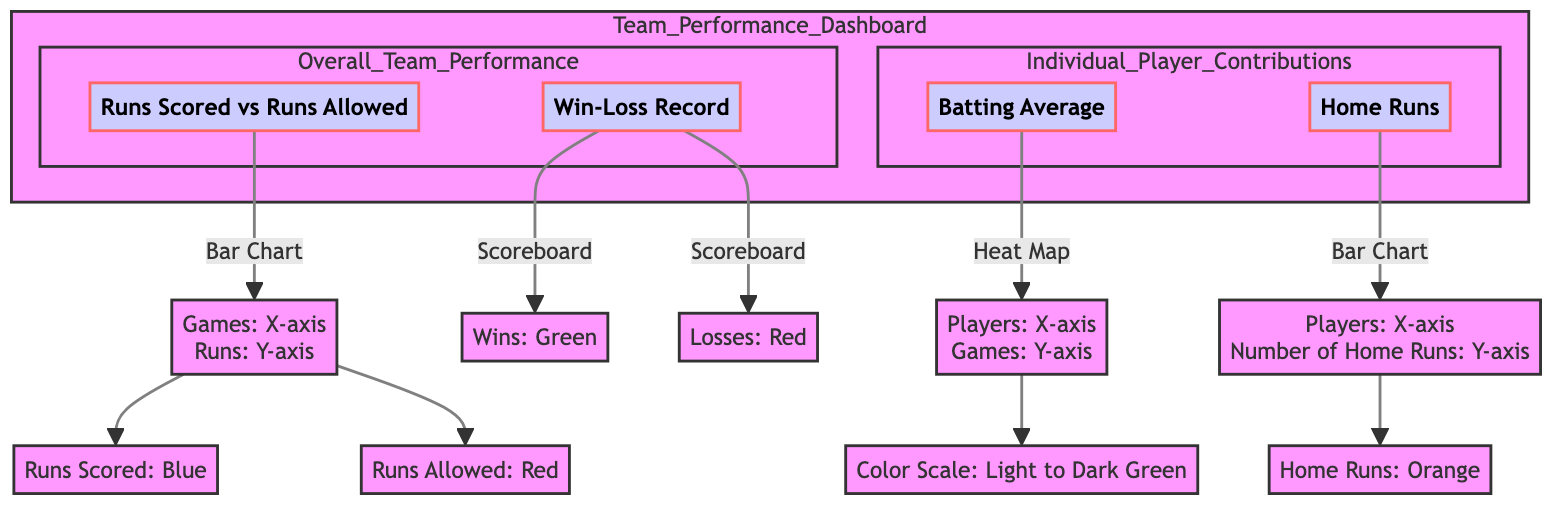What are the two main components of the Team Performance Dashboard? The diagram consists of two main components: "Overall Team Performance" and "Individual Player Contributions." These components are illustrated in the subgraphs, clearly separating the focus areas of the team's performance.
Answer: Overall Team Performance, Individual Player Contributions Which type of chart is used for "Runs Scored vs Runs Allowed"? The diagram specifies that "Runs Scored vs Runs Allowed" is represented by a bar chart, shown as a specific connection from node A to the chart node E.
Answer: Bar Chart What color represents wins in the Win-Loss Record section? The diagram indicates that wins are represented in green in the scoreboard connected to the win-loss record node B.
Answer: Green How many distinct players’ contributions are being monitored in the Individual Player Contributions section? In the diagram, the section for Individual Player Contributions includes two nodes: "Batting Average" and "Home Runs," showing that there are two distinct player contributions monitored in this section.
Answer: 2 What does the color scale in the batting average heat map range from? The diagram mentions that the color scale in the batting average heat map ranges from light to dark green, indicating a gradient that likely represents performance levels.
Answer: Light to Dark Green How do the runs scored and runs allowed relate to the games played? The diagram illustrates that the runs scored and runs allowed are plotted on the y-axis against the games played on the x-axis of the bar chart, establishing a direct relationship where games inform the measures of runs.
Answer: Directly related Which visualization method shows the number of home runs per player? The diagram shows that a bar chart is used to represent the number of home runs per player, as indicated by the specific connection from node D to the chart node L.
Answer: Bar Chart What is the significance of the colors used in the scoreboard for wins and losses? In the diagram, the use of green for wins and red for losses provides a clear visual cue to quickly assess the team's performance in terms of success and failure within a singular view.
Answer: Clear visual cue What is the connection style of the nodes in this diagram? The nodes in the diagram are connected using a default link style that denotes a stroke width of 2 pixels, with gray as the fill color, which visually differentiates them and helps maintain a structured layout.
Answer: Gray, stroke width 2px 